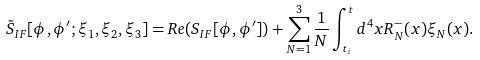<formula> <loc_0><loc_0><loc_500><loc_500>\tilde { S } _ { I F } [ \phi , \phi ^ { \prime } ; \xi _ { 1 } , \xi _ { 2 } , \xi _ { 3 } ] = R e ( S _ { I F } [ \phi , \phi ^ { \prime } ] ) + \sum _ { N = 1 } ^ { 3 } \frac { 1 } { N } \int _ { t _ { i } } ^ { t } d ^ { 4 } x R _ { N } ^ { - } ( x ) \xi _ { N } ( x ) .</formula> 